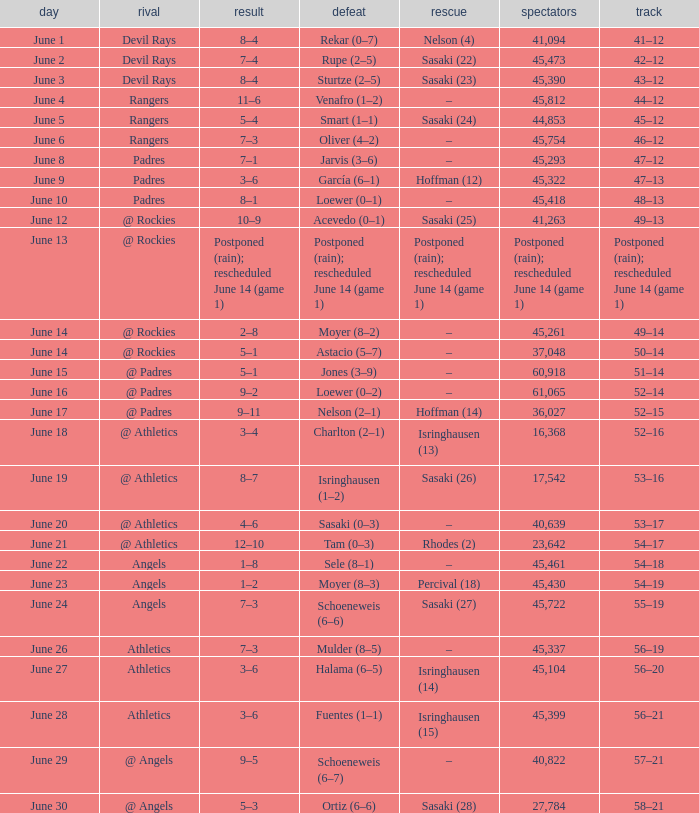What was the score of the Mariners game when they had a record of 56–21? 3–6. 